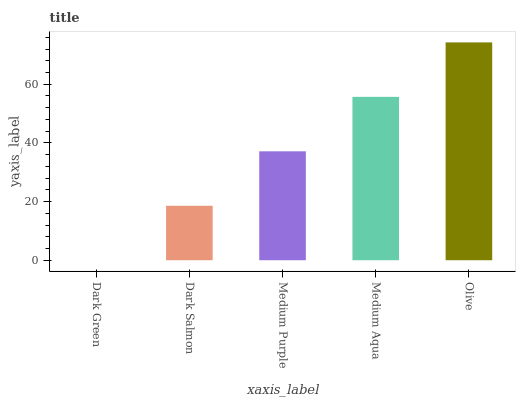Is Dark Green the minimum?
Answer yes or no. Yes. Is Olive the maximum?
Answer yes or no. Yes. Is Dark Salmon the minimum?
Answer yes or no. No. Is Dark Salmon the maximum?
Answer yes or no. No. Is Dark Salmon greater than Dark Green?
Answer yes or no. Yes. Is Dark Green less than Dark Salmon?
Answer yes or no. Yes. Is Dark Green greater than Dark Salmon?
Answer yes or no. No. Is Dark Salmon less than Dark Green?
Answer yes or no. No. Is Medium Purple the high median?
Answer yes or no. Yes. Is Medium Purple the low median?
Answer yes or no. Yes. Is Olive the high median?
Answer yes or no. No. Is Olive the low median?
Answer yes or no. No. 